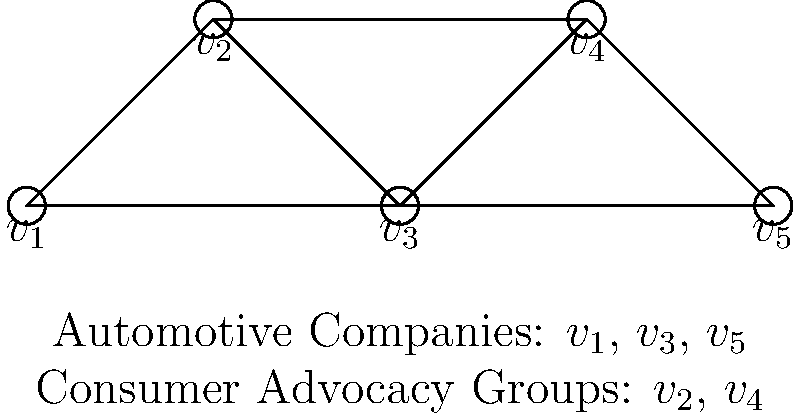In the graph above, vertices represent automotive companies ($v_1$, $v_3$, $v_5$) and consumer advocacy groups ($v_2$, $v_4$). Edges indicate potential conflicts of interest. What is the minimum number of colors needed to color the vertices such that no two adjacent vertices have the same color, and what legal principle does this coloring represent? To solve this graph coloring problem and understand its legal implications, let's follow these steps:

1. Analyze the graph structure:
   - The graph has 5 vertices ($v_1$ to $v_5$).
   - Edges connect vertices with potential conflicts of interest.

2. Apply the graph coloring algorithm:
   - Start with $v_1$ and assign it color 1.
   - $v_2$ is adjacent to $v_1$, so it needs a different color (color 2).
   - $v_3$ is adjacent to both $v_1$ and $v_2$, so it needs a third color (color 3).
   - $v_4$ is adjacent to $v_2$ and $v_3$, but not $v_1$, so it can use color 1.
   - $v_5$ is adjacent to $v_3$ and $v_4$, so it can use color 2.

3. Count the minimum number of colors used: 3 colors

4. Interpret the legal principle:
   - The coloring represents the separation of interests between automotive companies and consumer advocacy groups.
   - Each color group can be viewed as a set of entities that can interact without direct conflicts of interest.
   - This coloring scheme ensures that no automotive company is directly connected to a consumer advocacy group of the same color, maintaining independence and avoiding direct conflicts.

5. Legal relevance:
   - In consumer protection law, this principle is akin to maintaining independence between industry players and watchdog groups.
   - It helps ensure that consumer advocacy groups can operate without undue influence from the automotive companies they may need to scrutinize or challenge.
   - The coloring scheme could be used to design ethical guidelines or regulatory frameworks that prevent conflicts of interest while allowing necessary interactions within the industry.
Answer: 3 colors; Separation of interests 